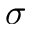<formula> <loc_0><loc_0><loc_500><loc_500>\sigma</formula> 